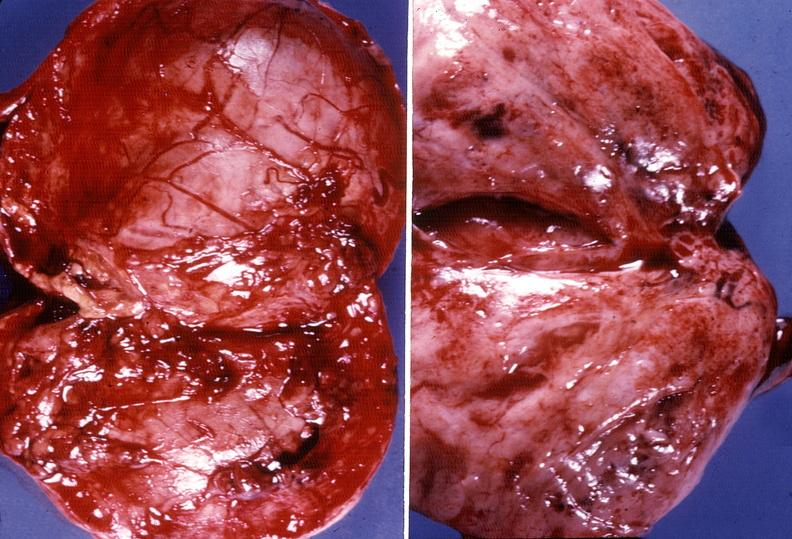does fibrinous peritonitis show adrenal phaeochromocytoma?
Answer the question using a single word or phrase. No 